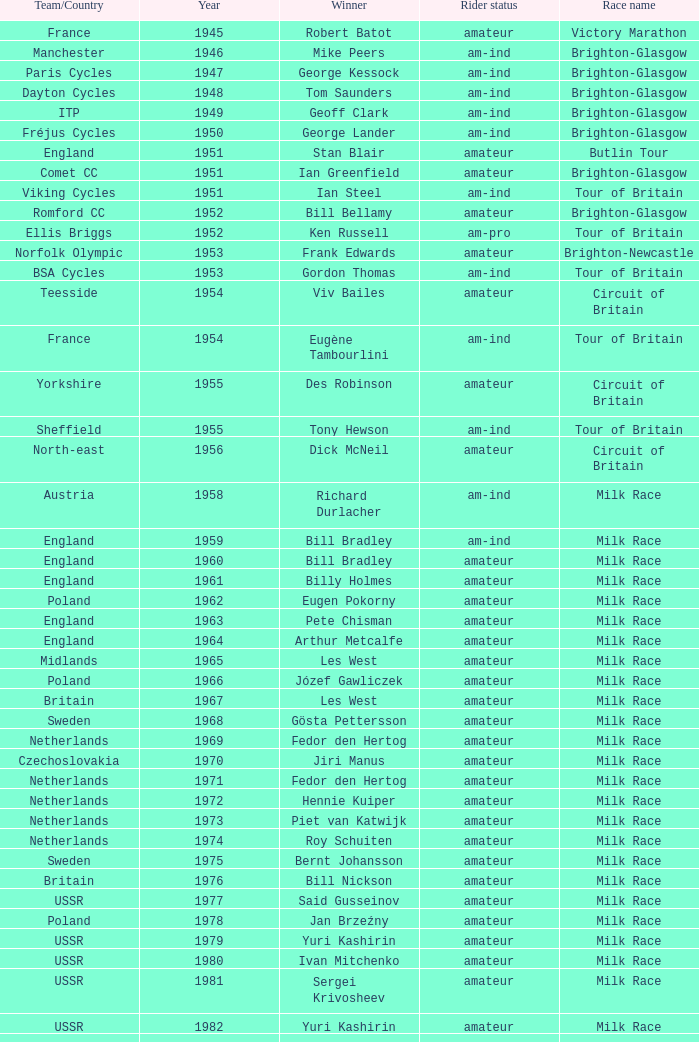What is the latest year when Phil Anderson won? 1993.0. 